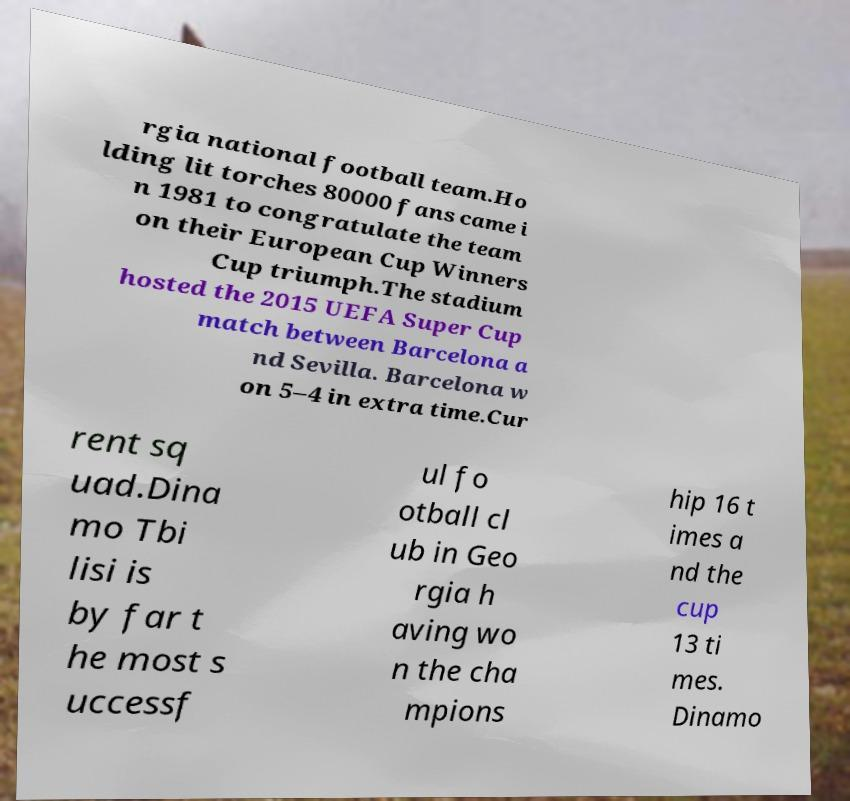Could you assist in decoding the text presented in this image and type it out clearly? rgia national football team.Ho lding lit torches 80000 fans came i n 1981 to congratulate the team on their European Cup Winners Cup triumph.The stadium hosted the 2015 UEFA Super Cup match between Barcelona a nd Sevilla. Barcelona w on 5–4 in extra time.Cur rent sq uad.Dina mo Tbi lisi is by far t he most s uccessf ul fo otball cl ub in Geo rgia h aving wo n the cha mpions hip 16 t imes a nd the cup 13 ti mes. Dinamo 